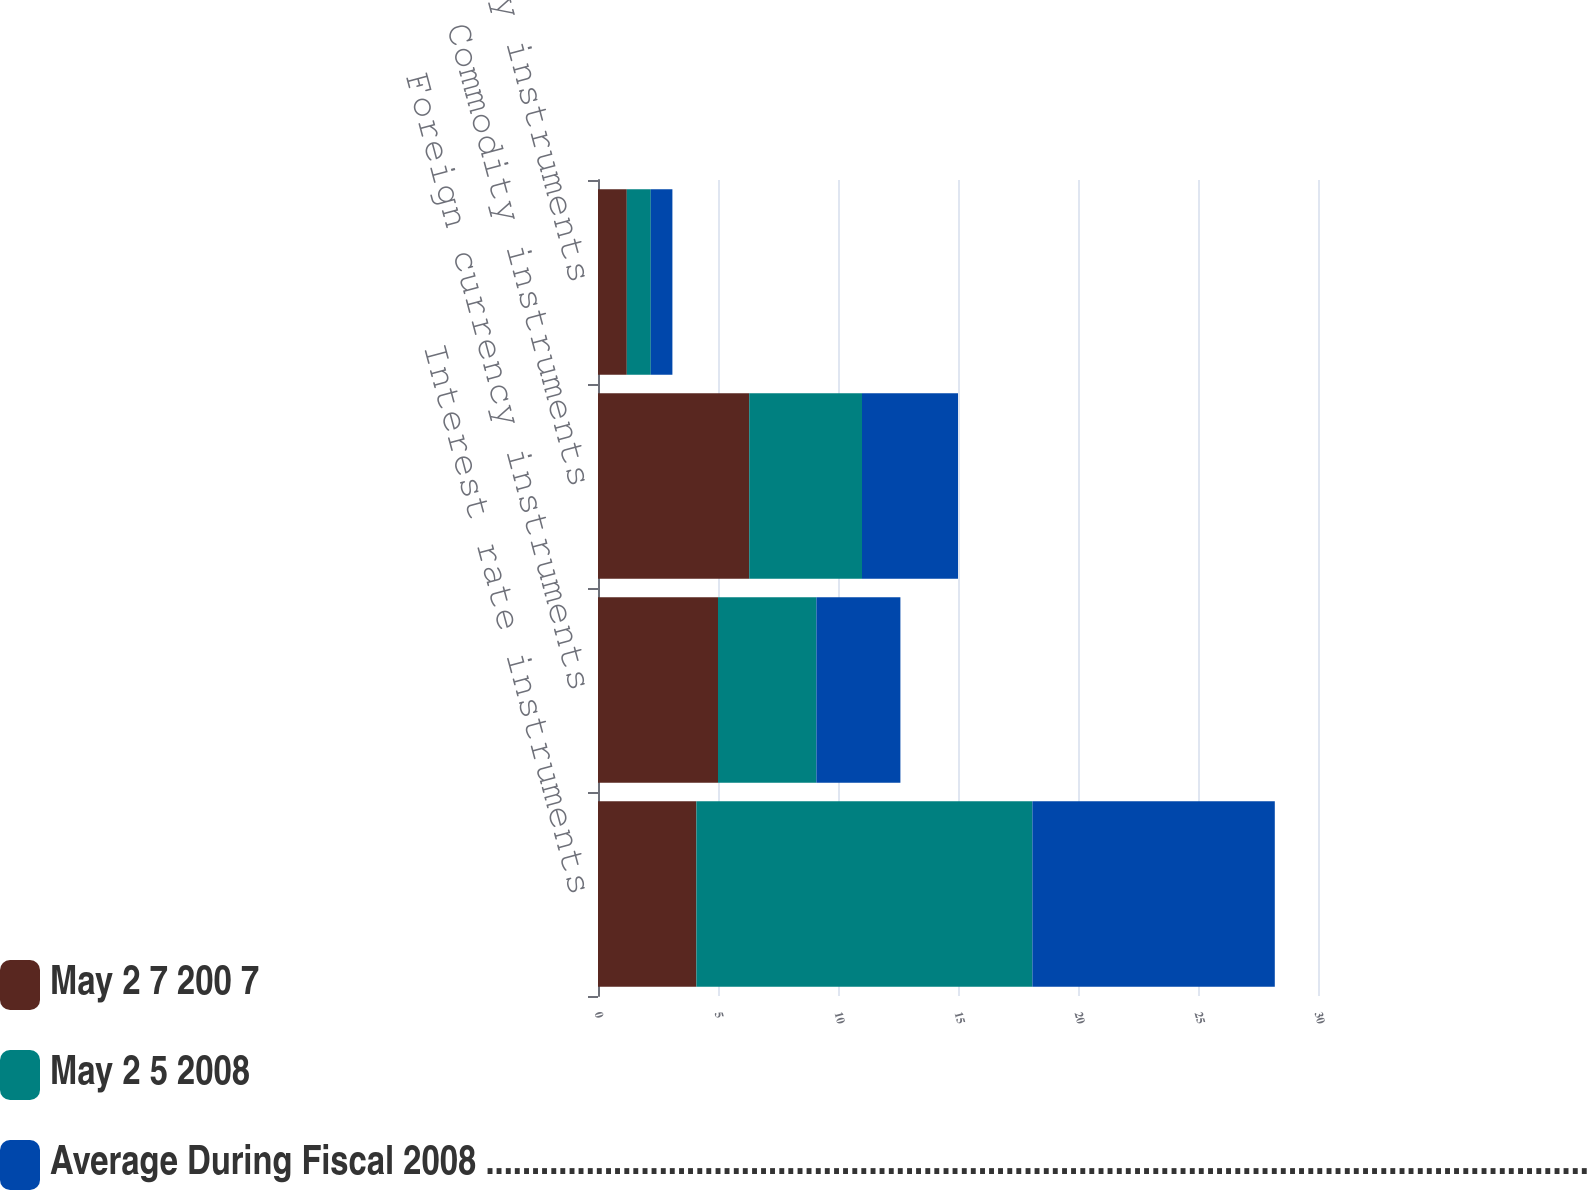Convert chart. <chart><loc_0><loc_0><loc_500><loc_500><stacked_bar_chart><ecel><fcel>Interest rate instruments<fcel>Foreign currency instruments<fcel>Commodity instruments<fcel>Equity instruments<nl><fcel>May 2 7 200 7<fcel>4.1<fcel>5<fcel>6.3<fcel>1.2<nl><fcel>May 2 5 2008<fcel>14<fcel>4.1<fcel>4.7<fcel>1<nl><fcel>Average During Fiscal 2008 .........................................................................................................................................................................................<fcel>10.1<fcel>3.5<fcel>4<fcel>0.9<nl></chart> 